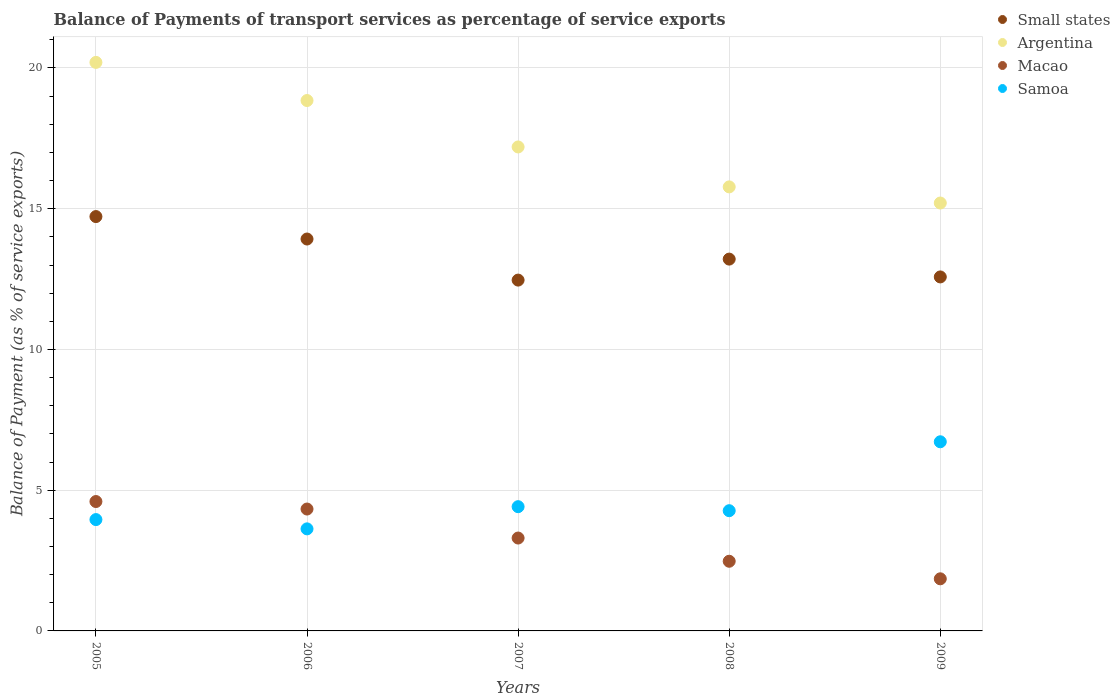What is the balance of payments of transport services in Small states in 2008?
Your response must be concise. 13.21. Across all years, what is the maximum balance of payments of transport services in Argentina?
Ensure brevity in your answer.  20.2. Across all years, what is the minimum balance of payments of transport services in Argentina?
Give a very brief answer. 15.2. In which year was the balance of payments of transport services in Samoa maximum?
Provide a succinct answer. 2009. What is the total balance of payments of transport services in Samoa in the graph?
Make the answer very short. 22.99. What is the difference between the balance of payments of transport services in Samoa in 2005 and that in 2009?
Give a very brief answer. -2.76. What is the difference between the balance of payments of transport services in Macao in 2009 and the balance of payments of transport services in Samoa in 2008?
Your response must be concise. -2.42. What is the average balance of payments of transport services in Small states per year?
Ensure brevity in your answer.  13.38. In the year 2005, what is the difference between the balance of payments of transport services in Argentina and balance of payments of transport services in Samoa?
Keep it short and to the point. 16.24. What is the ratio of the balance of payments of transport services in Macao in 2006 to that in 2009?
Ensure brevity in your answer.  2.34. What is the difference between the highest and the second highest balance of payments of transport services in Macao?
Your answer should be very brief. 0.27. What is the difference between the highest and the lowest balance of payments of transport services in Samoa?
Provide a succinct answer. 3.09. In how many years, is the balance of payments of transport services in Macao greater than the average balance of payments of transport services in Macao taken over all years?
Your response must be concise. 2. Is the sum of the balance of payments of transport services in Argentina in 2008 and 2009 greater than the maximum balance of payments of transport services in Small states across all years?
Your answer should be compact. Yes. Is it the case that in every year, the sum of the balance of payments of transport services in Samoa and balance of payments of transport services in Macao  is greater than the sum of balance of payments of transport services in Small states and balance of payments of transport services in Argentina?
Make the answer very short. No. Is it the case that in every year, the sum of the balance of payments of transport services in Small states and balance of payments of transport services in Macao  is greater than the balance of payments of transport services in Argentina?
Give a very brief answer. No. Does the balance of payments of transport services in Macao monotonically increase over the years?
Give a very brief answer. No. Is the balance of payments of transport services in Small states strictly less than the balance of payments of transport services in Macao over the years?
Make the answer very short. No. How many years are there in the graph?
Provide a short and direct response. 5. What is the difference between two consecutive major ticks on the Y-axis?
Your answer should be very brief. 5. Are the values on the major ticks of Y-axis written in scientific E-notation?
Your answer should be very brief. No. Does the graph contain any zero values?
Your answer should be very brief. No. Where does the legend appear in the graph?
Offer a very short reply. Top right. What is the title of the graph?
Your response must be concise. Balance of Payments of transport services as percentage of service exports. Does "Aruba" appear as one of the legend labels in the graph?
Give a very brief answer. No. What is the label or title of the X-axis?
Ensure brevity in your answer.  Years. What is the label or title of the Y-axis?
Your answer should be compact. Balance of Payment (as % of service exports). What is the Balance of Payment (as % of service exports) of Small states in 2005?
Ensure brevity in your answer.  14.72. What is the Balance of Payment (as % of service exports) in Argentina in 2005?
Offer a very short reply. 20.2. What is the Balance of Payment (as % of service exports) of Macao in 2005?
Your answer should be very brief. 4.6. What is the Balance of Payment (as % of service exports) in Samoa in 2005?
Your answer should be compact. 3.96. What is the Balance of Payment (as % of service exports) of Small states in 2006?
Keep it short and to the point. 13.92. What is the Balance of Payment (as % of service exports) in Argentina in 2006?
Keep it short and to the point. 18.84. What is the Balance of Payment (as % of service exports) of Macao in 2006?
Your answer should be compact. 4.33. What is the Balance of Payment (as % of service exports) in Samoa in 2006?
Make the answer very short. 3.63. What is the Balance of Payment (as % of service exports) of Small states in 2007?
Offer a terse response. 12.46. What is the Balance of Payment (as % of service exports) in Argentina in 2007?
Your answer should be very brief. 17.19. What is the Balance of Payment (as % of service exports) in Macao in 2007?
Offer a very short reply. 3.3. What is the Balance of Payment (as % of service exports) in Samoa in 2007?
Your response must be concise. 4.41. What is the Balance of Payment (as % of service exports) in Small states in 2008?
Your answer should be very brief. 13.21. What is the Balance of Payment (as % of service exports) of Argentina in 2008?
Offer a terse response. 15.78. What is the Balance of Payment (as % of service exports) of Macao in 2008?
Provide a succinct answer. 2.48. What is the Balance of Payment (as % of service exports) in Samoa in 2008?
Offer a terse response. 4.27. What is the Balance of Payment (as % of service exports) in Small states in 2009?
Your response must be concise. 12.58. What is the Balance of Payment (as % of service exports) in Argentina in 2009?
Your answer should be very brief. 15.2. What is the Balance of Payment (as % of service exports) of Macao in 2009?
Give a very brief answer. 1.85. What is the Balance of Payment (as % of service exports) of Samoa in 2009?
Provide a succinct answer. 6.72. Across all years, what is the maximum Balance of Payment (as % of service exports) in Small states?
Ensure brevity in your answer.  14.72. Across all years, what is the maximum Balance of Payment (as % of service exports) of Argentina?
Your response must be concise. 20.2. Across all years, what is the maximum Balance of Payment (as % of service exports) of Macao?
Give a very brief answer. 4.6. Across all years, what is the maximum Balance of Payment (as % of service exports) in Samoa?
Provide a succinct answer. 6.72. Across all years, what is the minimum Balance of Payment (as % of service exports) of Small states?
Make the answer very short. 12.46. Across all years, what is the minimum Balance of Payment (as % of service exports) in Argentina?
Provide a short and direct response. 15.2. Across all years, what is the minimum Balance of Payment (as % of service exports) of Macao?
Offer a terse response. 1.85. Across all years, what is the minimum Balance of Payment (as % of service exports) of Samoa?
Your answer should be very brief. 3.63. What is the total Balance of Payment (as % of service exports) of Small states in the graph?
Give a very brief answer. 66.89. What is the total Balance of Payment (as % of service exports) of Argentina in the graph?
Your response must be concise. 87.21. What is the total Balance of Payment (as % of service exports) of Macao in the graph?
Keep it short and to the point. 16.55. What is the total Balance of Payment (as % of service exports) in Samoa in the graph?
Keep it short and to the point. 22.99. What is the difference between the Balance of Payment (as % of service exports) of Small states in 2005 and that in 2006?
Offer a terse response. 0.8. What is the difference between the Balance of Payment (as % of service exports) of Argentina in 2005 and that in 2006?
Ensure brevity in your answer.  1.35. What is the difference between the Balance of Payment (as % of service exports) of Macao in 2005 and that in 2006?
Your answer should be very brief. 0.27. What is the difference between the Balance of Payment (as % of service exports) in Samoa in 2005 and that in 2006?
Provide a short and direct response. 0.33. What is the difference between the Balance of Payment (as % of service exports) in Small states in 2005 and that in 2007?
Make the answer very short. 2.26. What is the difference between the Balance of Payment (as % of service exports) of Argentina in 2005 and that in 2007?
Give a very brief answer. 3. What is the difference between the Balance of Payment (as % of service exports) in Macao in 2005 and that in 2007?
Ensure brevity in your answer.  1.3. What is the difference between the Balance of Payment (as % of service exports) in Samoa in 2005 and that in 2007?
Give a very brief answer. -0.46. What is the difference between the Balance of Payment (as % of service exports) in Small states in 2005 and that in 2008?
Your answer should be very brief. 1.51. What is the difference between the Balance of Payment (as % of service exports) in Argentina in 2005 and that in 2008?
Offer a very short reply. 4.42. What is the difference between the Balance of Payment (as % of service exports) in Macao in 2005 and that in 2008?
Keep it short and to the point. 2.12. What is the difference between the Balance of Payment (as % of service exports) of Samoa in 2005 and that in 2008?
Your response must be concise. -0.32. What is the difference between the Balance of Payment (as % of service exports) of Small states in 2005 and that in 2009?
Offer a terse response. 2.14. What is the difference between the Balance of Payment (as % of service exports) of Argentina in 2005 and that in 2009?
Your answer should be compact. 5. What is the difference between the Balance of Payment (as % of service exports) in Macao in 2005 and that in 2009?
Provide a short and direct response. 2.75. What is the difference between the Balance of Payment (as % of service exports) in Samoa in 2005 and that in 2009?
Ensure brevity in your answer.  -2.76. What is the difference between the Balance of Payment (as % of service exports) in Small states in 2006 and that in 2007?
Offer a very short reply. 1.46. What is the difference between the Balance of Payment (as % of service exports) of Argentina in 2006 and that in 2007?
Provide a succinct answer. 1.65. What is the difference between the Balance of Payment (as % of service exports) of Macao in 2006 and that in 2007?
Make the answer very short. 1.03. What is the difference between the Balance of Payment (as % of service exports) of Samoa in 2006 and that in 2007?
Ensure brevity in your answer.  -0.79. What is the difference between the Balance of Payment (as % of service exports) of Small states in 2006 and that in 2008?
Provide a short and direct response. 0.71. What is the difference between the Balance of Payment (as % of service exports) of Argentina in 2006 and that in 2008?
Your answer should be compact. 3.07. What is the difference between the Balance of Payment (as % of service exports) in Macao in 2006 and that in 2008?
Your answer should be compact. 1.86. What is the difference between the Balance of Payment (as % of service exports) of Samoa in 2006 and that in 2008?
Provide a succinct answer. -0.65. What is the difference between the Balance of Payment (as % of service exports) in Small states in 2006 and that in 2009?
Your response must be concise. 1.35. What is the difference between the Balance of Payment (as % of service exports) in Argentina in 2006 and that in 2009?
Your answer should be compact. 3.64. What is the difference between the Balance of Payment (as % of service exports) in Macao in 2006 and that in 2009?
Offer a very short reply. 2.48. What is the difference between the Balance of Payment (as % of service exports) of Samoa in 2006 and that in 2009?
Make the answer very short. -3.09. What is the difference between the Balance of Payment (as % of service exports) in Small states in 2007 and that in 2008?
Offer a terse response. -0.75. What is the difference between the Balance of Payment (as % of service exports) of Argentina in 2007 and that in 2008?
Your answer should be very brief. 1.42. What is the difference between the Balance of Payment (as % of service exports) in Macao in 2007 and that in 2008?
Your answer should be compact. 0.82. What is the difference between the Balance of Payment (as % of service exports) in Samoa in 2007 and that in 2008?
Offer a very short reply. 0.14. What is the difference between the Balance of Payment (as % of service exports) of Small states in 2007 and that in 2009?
Your response must be concise. -0.11. What is the difference between the Balance of Payment (as % of service exports) of Argentina in 2007 and that in 2009?
Offer a terse response. 1.99. What is the difference between the Balance of Payment (as % of service exports) of Macao in 2007 and that in 2009?
Give a very brief answer. 1.45. What is the difference between the Balance of Payment (as % of service exports) of Samoa in 2007 and that in 2009?
Provide a succinct answer. -2.31. What is the difference between the Balance of Payment (as % of service exports) in Small states in 2008 and that in 2009?
Ensure brevity in your answer.  0.63. What is the difference between the Balance of Payment (as % of service exports) of Argentina in 2008 and that in 2009?
Your answer should be very brief. 0.57. What is the difference between the Balance of Payment (as % of service exports) in Macao in 2008 and that in 2009?
Provide a succinct answer. 0.62. What is the difference between the Balance of Payment (as % of service exports) of Samoa in 2008 and that in 2009?
Your response must be concise. -2.45. What is the difference between the Balance of Payment (as % of service exports) of Small states in 2005 and the Balance of Payment (as % of service exports) of Argentina in 2006?
Ensure brevity in your answer.  -4.12. What is the difference between the Balance of Payment (as % of service exports) in Small states in 2005 and the Balance of Payment (as % of service exports) in Macao in 2006?
Your answer should be very brief. 10.39. What is the difference between the Balance of Payment (as % of service exports) in Small states in 2005 and the Balance of Payment (as % of service exports) in Samoa in 2006?
Offer a terse response. 11.09. What is the difference between the Balance of Payment (as % of service exports) in Argentina in 2005 and the Balance of Payment (as % of service exports) in Macao in 2006?
Your answer should be compact. 15.87. What is the difference between the Balance of Payment (as % of service exports) in Argentina in 2005 and the Balance of Payment (as % of service exports) in Samoa in 2006?
Ensure brevity in your answer.  16.57. What is the difference between the Balance of Payment (as % of service exports) in Macao in 2005 and the Balance of Payment (as % of service exports) in Samoa in 2006?
Ensure brevity in your answer.  0.97. What is the difference between the Balance of Payment (as % of service exports) in Small states in 2005 and the Balance of Payment (as % of service exports) in Argentina in 2007?
Your response must be concise. -2.47. What is the difference between the Balance of Payment (as % of service exports) of Small states in 2005 and the Balance of Payment (as % of service exports) of Macao in 2007?
Your response must be concise. 11.42. What is the difference between the Balance of Payment (as % of service exports) of Small states in 2005 and the Balance of Payment (as % of service exports) of Samoa in 2007?
Offer a terse response. 10.31. What is the difference between the Balance of Payment (as % of service exports) in Argentina in 2005 and the Balance of Payment (as % of service exports) in Macao in 2007?
Make the answer very short. 16.9. What is the difference between the Balance of Payment (as % of service exports) in Argentina in 2005 and the Balance of Payment (as % of service exports) in Samoa in 2007?
Ensure brevity in your answer.  15.78. What is the difference between the Balance of Payment (as % of service exports) of Macao in 2005 and the Balance of Payment (as % of service exports) of Samoa in 2007?
Offer a very short reply. 0.18. What is the difference between the Balance of Payment (as % of service exports) of Small states in 2005 and the Balance of Payment (as % of service exports) of Argentina in 2008?
Make the answer very short. -1.05. What is the difference between the Balance of Payment (as % of service exports) in Small states in 2005 and the Balance of Payment (as % of service exports) in Macao in 2008?
Keep it short and to the point. 12.25. What is the difference between the Balance of Payment (as % of service exports) in Small states in 2005 and the Balance of Payment (as % of service exports) in Samoa in 2008?
Offer a terse response. 10.45. What is the difference between the Balance of Payment (as % of service exports) of Argentina in 2005 and the Balance of Payment (as % of service exports) of Macao in 2008?
Provide a succinct answer. 17.72. What is the difference between the Balance of Payment (as % of service exports) of Argentina in 2005 and the Balance of Payment (as % of service exports) of Samoa in 2008?
Your answer should be compact. 15.93. What is the difference between the Balance of Payment (as % of service exports) of Macao in 2005 and the Balance of Payment (as % of service exports) of Samoa in 2008?
Provide a succinct answer. 0.33. What is the difference between the Balance of Payment (as % of service exports) of Small states in 2005 and the Balance of Payment (as % of service exports) of Argentina in 2009?
Your answer should be compact. -0.48. What is the difference between the Balance of Payment (as % of service exports) of Small states in 2005 and the Balance of Payment (as % of service exports) of Macao in 2009?
Make the answer very short. 12.87. What is the difference between the Balance of Payment (as % of service exports) of Small states in 2005 and the Balance of Payment (as % of service exports) of Samoa in 2009?
Keep it short and to the point. 8. What is the difference between the Balance of Payment (as % of service exports) of Argentina in 2005 and the Balance of Payment (as % of service exports) of Macao in 2009?
Make the answer very short. 18.35. What is the difference between the Balance of Payment (as % of service exports) of Argentina in 2005 and the Balance of Payment (as % of service exports) of Samoa in 2009?
Your answer should be compact. 13.48. What is the difference between the Balance of Payment (as % of service exports) in Macao in 2005 and the Balance of Payment (as % of service exports) in Samoa in 2009?
Ensure brevity in your answer.  -2.12. What is the difference between the Balance of Payment (as % of service exports) in Small states in 2006 and the Balance of Payment (as % of service exports) in Argentina in 2007?
Make the answer very short. -3.27. What is the difference between the Balance of Payment (as % of service exports) in Small states in 2006 and the Balance of Payment (as % of service exports) in Macao in 2007?
Keep it short and to the point. 10.62. What is the difference between the Balance of Payment (as % of service exports) in Small states in 2006 and the Balance of Payment (as % of service exports) in Samoa in 2007?
Offer a terse response. 9.51. What is the difference between the Balance of Payment (as % of service exports) in Argentina in 2006 and the Balance of Payment (as % of service exports) in Macao in 2007?
Give a very brief answer. 15.54. What is the difference between the Balance of Payment (as % of service exports) in Argentina in 2006 and the Balance of Payment (as % of service exports) in Samoa in 2007?
Keep it short and to the point. 14.43. What is the difference between the Balance of Payment (as % of service exports) in Macao in 2006 and the Balance of Payment (as % of service exports) in Samoa in 2007?
Your answer should be very brief. -0.08. What is the difference between the Balance of Payment (as % of service exports) in Small states in 2006 and the Balance of Payment (as % of service exports) in Argentina in 2008?
Provide a succinct answer. -1.85. What is the difference between the Balance of Payment (as % of service exports) of Small states in 2006 and the Balance of Payment (as % of service exports) of Macao in 2008?
Keep it short and to the point. 11.45. What is the difference between the Balance of Payment (as % of service exports) of Small states in 2006 and the Balance of Payment (as % of service exports) of Samoa in 2008?
Offer a terse response. 9.65. What is the difference between the Balance of Payment (as % of service exports) in Argentina in 2006 and the Balance of Payment (as % of service exports) in Macao in 2008?
Offer a terse response. 16.37. What is the difference between the Balance of Payment (as % of service exports) in Argentina in 2006 and the Balance of Payment (as % of service exports) in Samoa in 2008?
Keep it short and to the point. 14.57. What is the difference between the Balance of Payment (as % of service exports) of Macao in 2006 and the Balance of Payment (as % of service exports) of Samoa in 2008?
Give a very brief answer. 0.06. What is the difference between the Balance of Payment (as % of service exports) of Small states in 2006 and the Balance of Payment (as % of service exports) of Argentina in 2009?
Give a very brief answer. -1.28. What is the difference between the Balance of Payment (as % of service exports) in Small states in 2006 and the Balance of Payment (as % of service exports) in Macao in 2009?
Offer a terse response. 12.07. What is the difference between the Balance of Payment (as % of service exports) in Small states in 2006 and the Balance of Payment (as % of service exports) in Samoa in 2009?
Give a very brief answer. 7.2. What is the difference between the Balance of Payment (as % of service exports) of Argentina in 2006 and the Balance of Payment (as % of service exports) of Macao in 2009?
Provide a short and direct response. 16.99. What is the difference between the Balance of Payment (as % of service exports) of Argentina in 2006 and the Balance of Payment (as % of service exports) of Samoa in 2009?
Ensure brevity in your answer.  12.12. What is the difference between the Balance of Payment (as % of service exports) of Macao in 2006 and the Balance of Payment (as % of service exports) of Samoa in 2009?
Your answer should be very brief. -2.39. What is the difference between the Balance of Payment (as % of service exports) in Small states in 2007 and the Balance of Payment (as % of service exports) in Argentina in 2008?
Your response must be concise. -3.31. What is the difference between the Balance of Payment (as % of service exports) of Small states in 2007 and the Balance of Payment (as % of service exports) of Macao in 2008?
Keep it short and to the point. 9.99. What is the difference between the Balance of Payment (as % of service exports) of Small states in 2007 and the Balance of Payment (as % of service exports) of Samoa in 2008?
Give a very brief answer. 8.19. What is the difference between the Balance of Payment (as % of service exports) in Argentina in 2007 and the Balance of Payment (as % of service exports) in Macao in 2008?
Provide a short and direct response. 14.72. What is the difference between the Balance of Payment (as % of service exports) of Argentina in 2007 and the Balance of Payment (as % of service exports) of Samoa in 2008?
Offer a very short reply. 12.92. What is the difference between the Balance of Payment (as % of service exports) of Macao in 2007 and the Balance of Payment (as % of service exports) of Samoa in 2008?
Your answer should be compact. -0.97. What is the difference between the Balance of Payment (as % of service exports) of Small states in 2007 and the Balance of Payment (as % of service exports) of Argentina in 2009?
Give a very brief answer. -2.74. What is the difference between the Balance of Payment (as % of service exports) of Small states in 2007 and the Balance of Payment (as % of service exports) of Macao in 2009?
Ensure brevity in your answer.  10.61. What is the difference between the Balance of Payment (as % of service exports) of Small states in 2007 and the Balance of Payment (as % of service exports) of Samoa in 2009?
Your answer should be very brief. 5.74. What is the difference between the Balance of Payment (as % of service exports) in Argentina in 2007 and the Balance of Payment (as % of service exports) in Macao in 2009?
Provide a succinct answer. 15.34. What is the difference between the Balance of Payment (as % of service exports) of Argentina in 2007 and the Balance of Payment (as % of service exports) of Samoa in 2009?
Your answer should be very brief. 10.47. What is the difference between the Balance of Payment (as % of service exports) in Macao in 2007 and the Balance of Payment (as % of service exports) in Samoa in 2009?
Offer a very short reply. -3.42. What is the difference between the Balance of Payment (as % of service exports) of Small states in 2008 and the Balance of Payment (as % of service exports) of Argentina in 2009?
Keep it short and to the point. -1.99. What is the difference between the Balance of Payment (as % of service exports) of Small states in 2008 and the Balance of Payment (as % of service exports) of Macao in 2009?
Keep it short and to the point. 11.36. What is the difference between the Balance of Payment (as % of service exports) of Small states in 2008 and the Balance of Payment (as % of service exports) of Samoa in 2009?
Your response must be concise. 6.49. What is the difference between the Balance of Payment (as % of service exports) of Argentina in 2008 and the Balance of Payment (as % of service exports) of Macao in 2009?
Ensure brevity in your answer.  13.92. What is the difference between the Balance of Payment (as % of service exports) of Argentina in 2008 and the Balance of Payment (as % of service exports) of Samoa in 2009?
Provide a short and direct response. 9.06. What is the difference between the Balance of Payment (as % of service exports) of Macao in 2008 and the Balance of Payment (as % of service exports) of Samoa in 2009?
Your answer should be very brief. -4.24. What is the average Balance of Payment (as % of service exports) of Small states per year?
Give a very brief answer. 13.38. What is the average Balance of Payment (as % of service exports) of Argentina per year?
Your answer should be very brief. 17.44. What is the average Balance of Payment (as % of service exports) of Macao per year?
Keep it short and to the point. 3.31. What is the average Balance of Payment (as % of service exports) in Samoa per year?
Your response must be concise. 4.6. In the year 2005, what is the difference between the Balance of Payment (as % of service exports) in Small states and Balance of Payment (as % of service exports) in Argentina?
Your answer should be compact. -5.48. In the year 2005, what is the difference between the Balance of Payment (as % of service exports) of Small states and Balance of Payment (as % of service exports) of Macao?
Make the answer very short. 10.12. In the year 2005, what is the difference between the Balance of Payment (as % of service exports) in Small states and Balance of Payment (as % of service exports) in Samoa?
Provide a succinct answer. 10.77. In the year 2005, what is the difference between the Balance of Payment (as % of service exports) in Argentina and Balance of Payment (as % of service exports) in Macao?
Provide a succinct answer. 15.6. In the year 2005, what is the difference between the Balance of Payment (as % of service exports) of Argentina and Balance of Payment (as % of service exports) of Samoa?
Keep it short and to the point. 16.24. In the year 2005, what is the difference between the Balance of Payment (as % of service exports) of Macao and Balance of Payment (as % of service exports) of Samoa?
Ensure brevity in your answer.  0.64. In the year 2006, what is the difference between the Balance of Payment (as % of service exports) of Small states and Balance of Payment (as % of service exports) of Argentina?
Give a very brief answer. -4.92. In the year 2006, what is the difference between the Balance of Payment (as % of service exports) in Small states and Balance of Payment (as % of service exports) in Macao?
Provide a short and direct response. 9.59. In the year 2006, what is the difference between the Balance of Payment (as % of service exports) in Small states and Balance of Payment (as % of service exports) in Samoa?
Offer a very short reply. 10.3. In the year 2006, what is the difference between the Balance of Payment (as % of service exports) in Argentina and Balance of Payment (as % of service exports) in Macao?
Give a very brief answer. 14.51. In the year 2006, what is the difference between the Balance of Payment (as % of service exports) of Argentina and Balance of Payment (as % of service exports) of Samoa?
Offer a very short reply. 15.22. In the year 2006, what is the difference between the Balance of Payment (as % of service exports) of Macao and Balance of Payment (as % of service exports) of Samoa?
Offer a terse response. 0.7. In the year 2007, what is the difference between the Balance of Payment (as % of service exports) in Small states and Balance of Payment (as % of service exports) in Argentina?
Your answer should be compact. -4.73. In the year 2007, what is the difference between the Balance of Payment (as % of service exports) in Small states and Balance of Payment (as % of service exports) in Macao?
Offer a very short reply. 9.16. In the year 2007, what is the difference between the Balance of Payment (as % of service exports) in Small states and Balance of Payment (as % of service exports) in Samoa?
Ensure brevity in your answer.  8.05. In the year 2007, what is the difference between the Balance of Payment (as % of service exports) in Argentina and Balance of Payment (as % of service exports) in Macao?
Provide a succinct answer. 13.89. In the year 2007, what is the difference between the Balance of Payment (as % of service exports) in Argentina and Balance of Payment (as % of service exports) in Samoa?
Ensure brevity in your answer.  12.78. In the year 2007, what is the difference between the Balance of Payment (as % of service exports) in Macao and Balance of Payment (as % of service exports) in Samoa?
Offer a very short reply. -1.11. In the year 2008, what is the difference between the Balance of Payment (as % of service exports) of Small states and Balance of Payment (as % of service exports) of Argentina?
Your response must be concise. -2.57. In the year 2008, what is the difference between the Balance of Payment (as % of service exports) in Small states and Balance of Payment (as % of service exports) in Macao?
Provide a succinct answer. 10.73. In the year 2008, what is the difference between the Balance of Payment (as % of service exports) in Small states and Balance of Payment (as % of service exports) in Samoa?
Your response must be concise. 8.94. In the year 2008, what is the difference between the Balance of Payment (as % of service exports) in Argentina and Balance of Payment (as % of service exports) in Macao?
Your response must be concise. 13.3. In the year 2008, what is the difference between the Balance of Payment (as % of service exports) of Argentina and Balance of Payment (as % of service exports) of Samoa?
Give a very brief answer. 11.5. In the year 2008, what is the difference between the Balance of Payment (as % of service exports) in Macao and Balance of Payment (as % of service exports) in Samoa?
Offer a very short reply. -1.8. In the year 2009, what is the difference between the Balance of Payment (as % of service exports) in Small states and Balance of Payment (as % of service exports) in Argentina?
Offer a terse response. -2.63. In the year 2009, what is the difference between the Balance of Payment (as % of service exports) in Small states and Balance of Payment (as % of service exports) in Macao?
Your response must be concise. 10.72. In the year 2009, what is the difference between the Balance of Payment (as % of service exports) of Small states and Balance of Payment (as % of service exports) of Samoa?
Make the answer very short. 5.86. In the year 2009, what is the difference between the Balance of Payment (as % of service exports) in Argentina and Balance of Payment (as % of service exports) in Macao?
Your answer should be compact. 13.35. In the year 2009, what is the difference between the Balance of Payment (as % of service exports) of Argentina and Balance of Payment (as % of service exports) of Samoa?
Provide a succinct answer. 8.48. In the year 2009, what is the difference between the Balance of Payment (as % of service exports) in Macao and Balance of Payment (as % of service exports) in Samoa?
Provide a short and direct response. -4.87. What is the ratio of the Balance of Payment (as % of service exports) in Small states in 2005 to that in 2006?
Your answer should be very brief. 1.06. What is the ratio of the Balance of Payment (as % of service exports) of Argentina in 2005 to that in 2006?
Your answer should be compact. 1.07. What is the ratio of the Balance of Payment (as % of service exports) in Macao in 2005 to that in 2006?
Provide a succinct answer. 1.06. What is the ratio of the Balance of Payment (as % of service exports) of Samoa in 2005 to that in 2006?
Provide a short and direct response. 1.09. What is the ratio of the Balance of Payment (as % of service exports) of Small states in 2005 to that in 2007?
Give a very brief answer. 1.18. What is the ratio of the Balance of Payment (as % of service exports) of Argentina in 2005 to that in 2007?
Offer a terse response. 1.17. What is the ratio of the Balance of Payment (as % of service exports) of Macao in 2005 to that in 2007?
Provide a succinct answer. 1.39. What is the ratio of the Balance of Payment (as % of service exports) in Samoa in 2005 to that in 2007?
Provide a short and direct response. 0.9. What is the ratio of the Balance of Payment (as % of service exports) in Small states in 2005 to that in 2008?
Provide a short and direct response. 1.11. What is the ratio of the Balance of Payment (as % of service exports) of Argentina in 2005 to that in 2008?
Offer a very short reply. 1.28. What is the ratio of the Balance of Payment (as % of service exports) in Macao in 2005 to that in 2008?
Your answer should be compact. 1.86. What is the ratio of the Balance of Payment (as % of service exports) of Samoa in 2005 to that in 2008?
Offer a very short reply. 0.93. What is the ratio of the Balance of Payment (as % of service exports) in Small states in 2005 to that in 2009?
Offer a very short reply. 1.17. What is the ratio of the Balance of Payment (as % of service exports) in Argentina in 2005 to that in 2009?
Your answer should be very brief. 1.33. What is the ratio of the Balance of Payment (as % of service exports) in Macao in 2005 to that in 2009?
Provide a short and direct response. 2.48. What is the ratio of the Balance of Payment (as % of service exports) in Samoa in 2005 to that in 2009?
Provide a short and direct response. 0.59. What is the ratio of the Balance of Payment (as % of service exports) in Small states in 2006 to that in 2007?
Make the answer very short. 1.12. What is the ratio of the Balance of Payment (as % of service exports) in Argentina in 2006 to that in 2007?
Offer a very short reply. 1.1. What is the ratio of the Balance of Payment (as % of service exports) in Macao in 2006 to that in 2007?
Ensure brevity in your answer.  1.31. What is the ratio of the Balance of Payment (as % of service exports) in Samoa in 2006 to that in 2007?
Ensure brevity in your answer.  0.82. What is the ratio of the Balance of Payment (as % of service exports) of Small states in 2006 to that in 2008?
Your response must be concise. 1.05. What is the ratio of the Balance of Payment (as % of service exports) in Argentina in 2006 to that in 2008?
Your answer should be very brief. 1.19. What is the ratio of the Balance of Payment (as % of service exports) in Macao in 2006 to that in 2008?
Your answer should be compact. 1.75. What is the ratio of the Balance of Payment (as % of service exports) in Samoa in 2006 to that in 2008?
Make the answer very short. 0.85. What is the ratio of the Balance of Payment (as % of service exports) of Small states in 2006 to that in 2009?
Give a very brief answer. 1.11. What is the ratio of the Balance of Payment (as % of service exports) of Argentina in 2006 to that in 2009?
Keep it short and to the point. 1.24. What is the ratio of the Balance of Payment (as % of service exports) of Macao in 2006 to that in 2009?
Make the answer very short. 2.34. What is the ratio of the Balance of Payment (as % of service exports) of Samoa in 2006 to that in 2009?
Provide a succinct answer. 0.54. What is the ratio of the Balance of Payment (as % of service exports) in Small states in 2007 to that in 2008?
Provide a succinct answer. 0.94. What is the ratio of the Balance of Payment (as % of service exports) of Argentina in 2007 to that in 2008?
Give a very brief answer. 1.09. What is the ratio of the Balance of Payment (as % of service exports) in Samoa in 2007 to that in 2008?
Your answer should be compact. 1.03. What is the ratio of the Balance of Payment (as % of service exports) in Argentina in 2007 to that in 2009?
Provide a succinct answer. 1.13. What is the ratio of the Balance of Payment (as % of service exports) in Macao in 2007 to that in 2009?
Your answer should be compact. 1.78. What is the ratio of the Balance of Payment (as % of service exports) in Samoa in 2007 to that in 2009?
Offer a very short reply. 0.66. What is the ratio of the Balance of Payment (as % of service exports) of Small states in 2008 to that in 2009?
Give a very brief answer. 1.05. What is the ratio of the Balance of Payment (as % of service exports) of Argentina in 2008 to that in 2009?
Ensure brevity in your answer.  1.04. What is the ratio of the Balance of Payment (as % of service exports) of Macao in 2008 to that in 2009?
Offer a terse response. 1.34. What is the ratio of the Balance of Payment (as % of service exports) in Samoa in 2008 to that in 2009?
Your answer should be very brief. 0.64. What is the difference between the highest and the second highest Balance of Payment (as % of service exports) of Small states?
Make the answer very short. 0.8. What is the difference between the highest and the second highest Balance of Payment (as % of service exports) of Argentina?
Your answer should be very brief. 1.35. What is the difference between the highest and the second highest Balance of Payment (as % of service exports) in Macao?
Keep it short and to the point. 0.27. What is the difference between the highest and the second highest Balance of Payment (as % of service exports) of Samoa?
Keep it short and to the point. 2.31. What is the difference between the highest and the lowest Balance of Payment (as % of service exports) in Small states?
Offer a very short reply. 2.26. What is the difference between the highest and the lowest Balance of Payment (as % of service exports) of Argentina?
Give a very brief answer. 5. What is the difference between the highest and the lowest Balance of Payment (as % of service exports) of Macao?
Offer a terse response. 2.75. What is the difference between the highest and the lowest Balance of Payment (as % of service exports) in Samoa?
Offer a terse response. 3.09. 